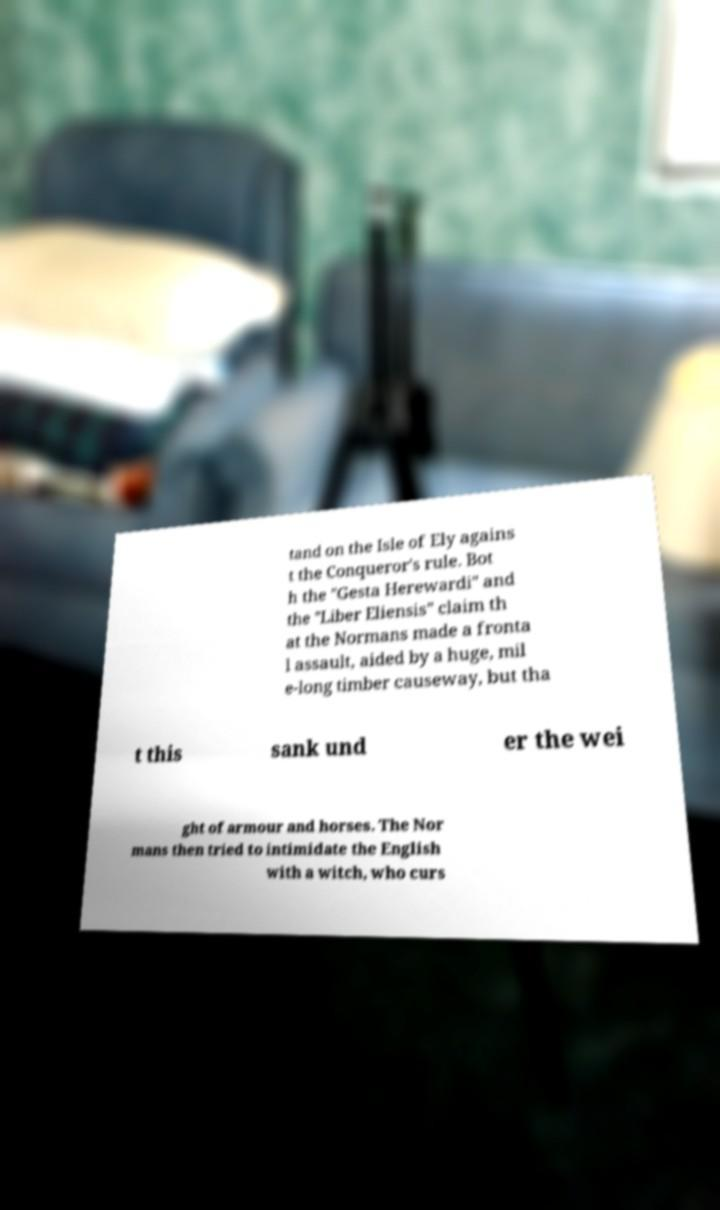What messages or text are displayed in this image? I need them in a readable, typed format. tand on the Isle of Ely agains t the Conqueror's rule. Bot h the "Gesta Herewardi" and the "Liber Eliensis" claim th at the Normans made a fronta l assault, aided by a huge, mil e-long timber causeway, but tha t this sank und er the wei ght of armour and horses. The Nor mans then tried to intimidate the English with a witch, who curs 